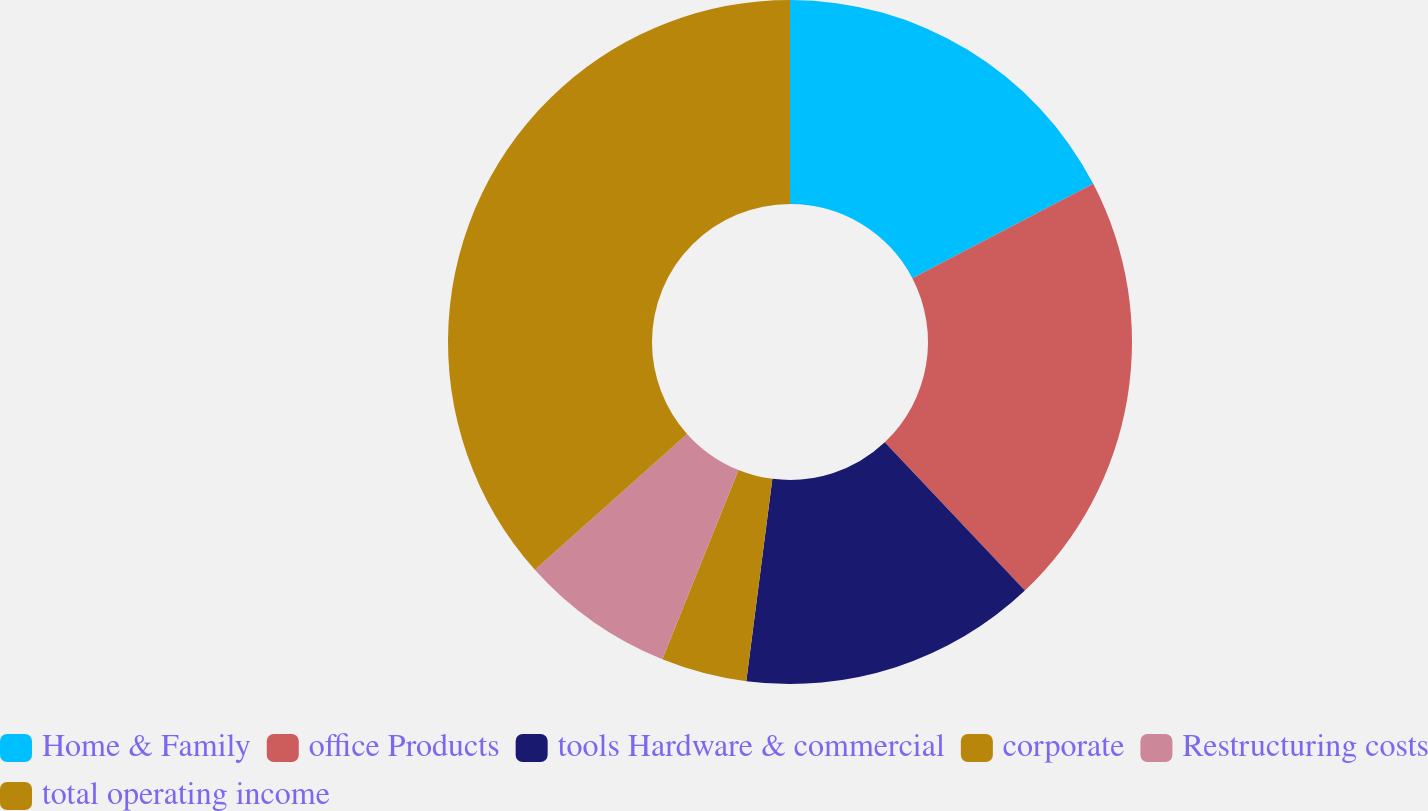Convert chart. <chart><loc_0><loc_0><loc_500><loc_500><pie_chart><fcel>Home & Family<fcel>office Products<fcel>tools Hardware & commercial<fcel>corporate<fcel>Restructuring costs<fcel>total operating income<nl><fcel>17.35%<fcel>20.6%<fcel>14.09%<fcel>4.05%<fcel>7.31%<fcel>36.6%<nl></chart> 